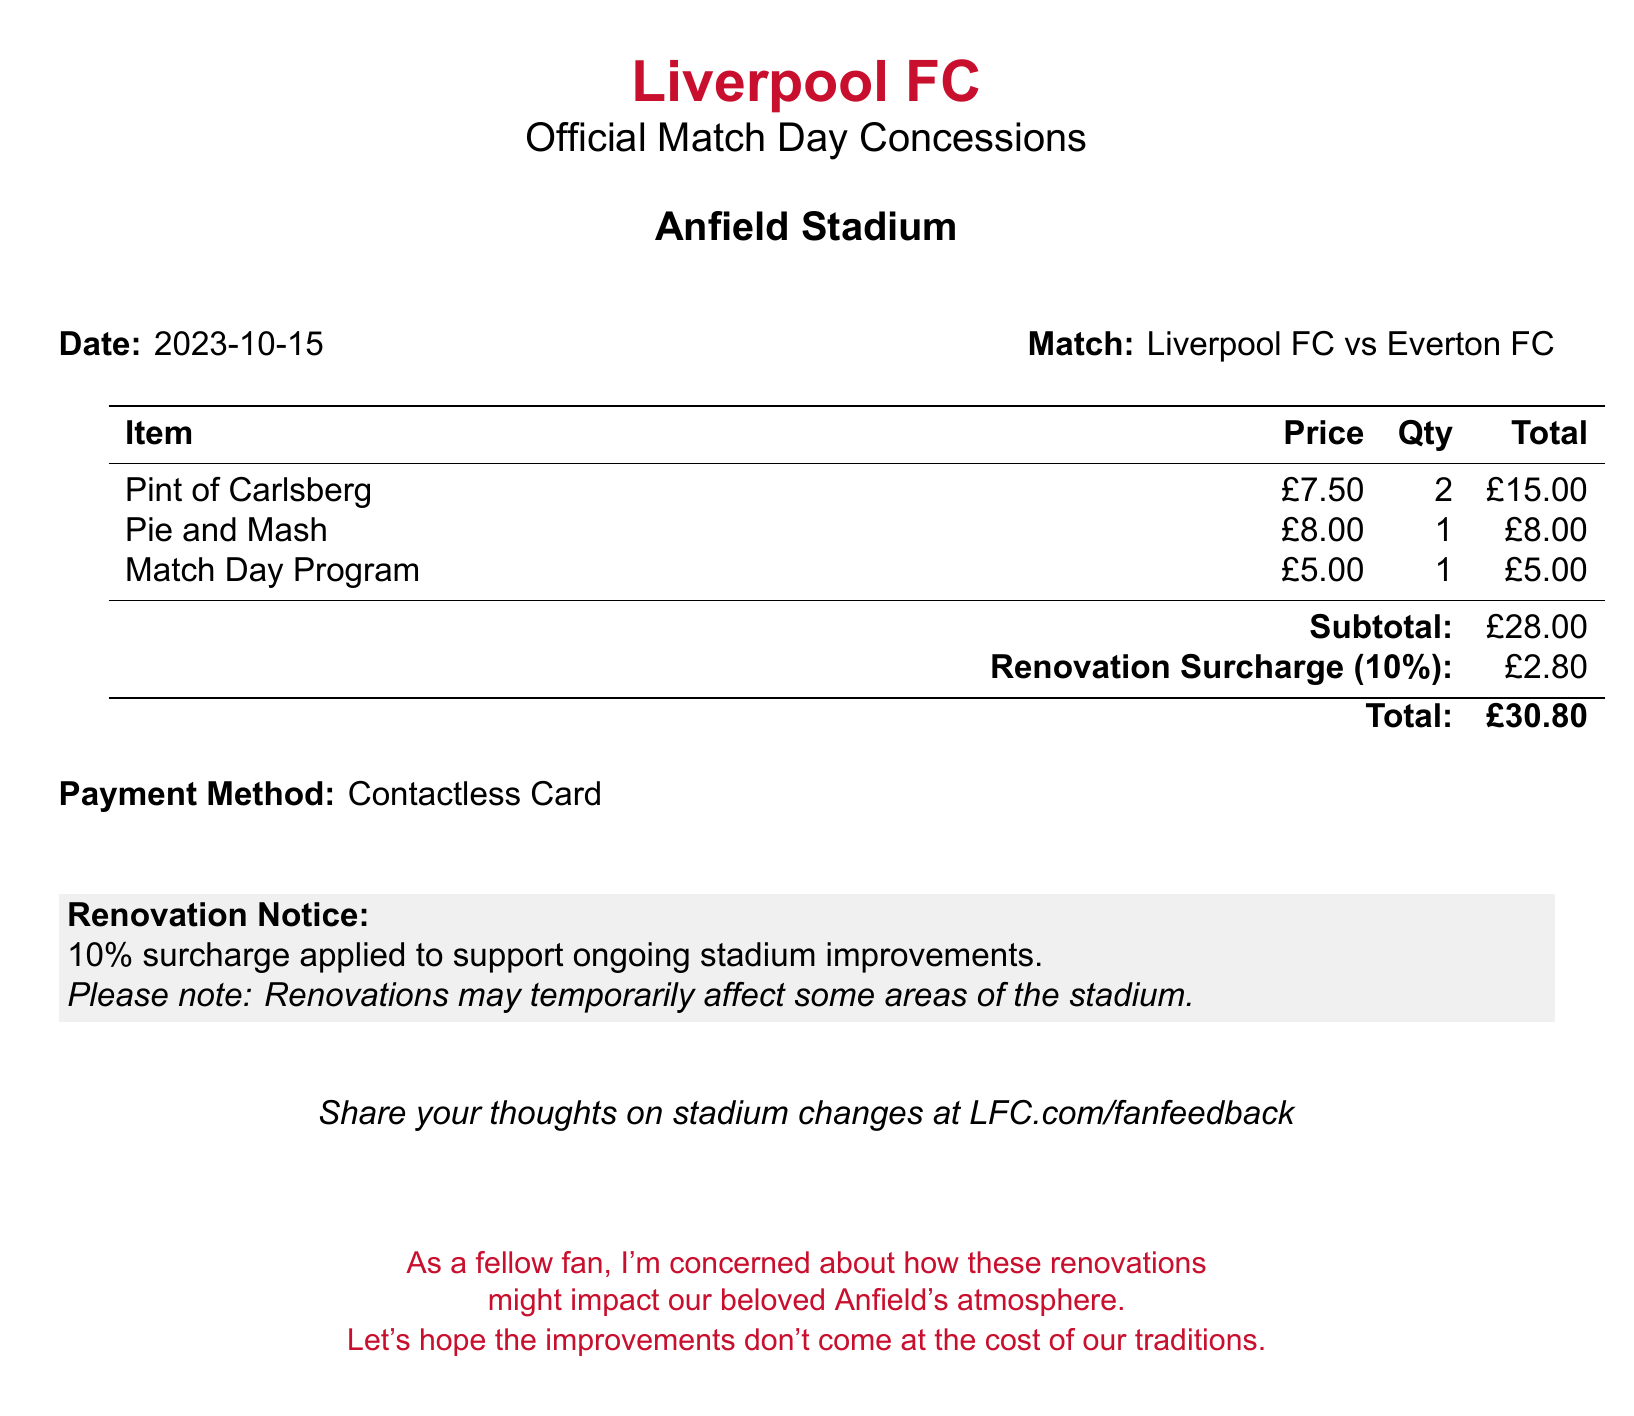What is the date of the match? The date of the match is explicitly stated in the document as "2023-10-15."
Answer: 2023-10-15 What is the total amount due? The total amount due is clearly listed at the bottom of the bill as "£30.80."
Answer: £30.80 How much is the renovation surcharge? The renovation surcharge of 10% is noted in the document as "£2.80."
Answer: £2.80 What item costs the most? The item with the highest cost is identified in the list as "Pie and Mash" at £8.00.
Answer: Pie and Mash What is the quantity of pints purchased? The quantity of pints (Carlsberg) purchased is given in the document as "2."
Answer: 2 What is the subtotal before surcharges? The subtotal before any surcharges is specified as "£28.00."
Answer: £28.00 What method of payment was used? The payment method is mentioned in the document as "Contactless Card."
Answer: Contactless Card What percentage surcharge is applied? The document specifies that a surcharge of "10%" is applied for renovations.
Answer: 10% What is the venue of the match? The venue of the match is listed as "Anfield Stadium."
Answer: Anfield Stadium 